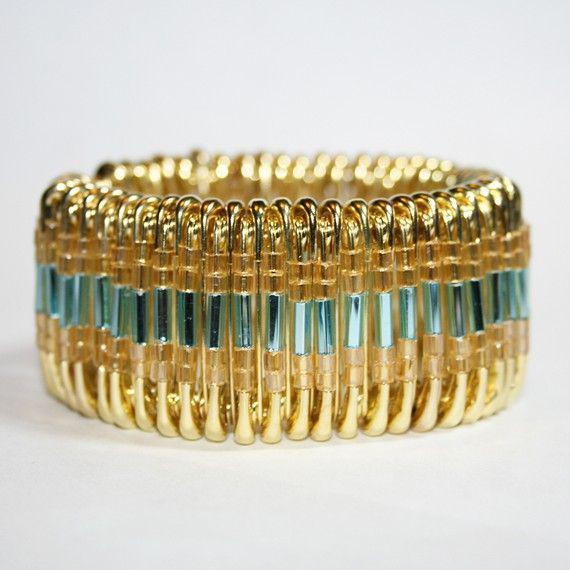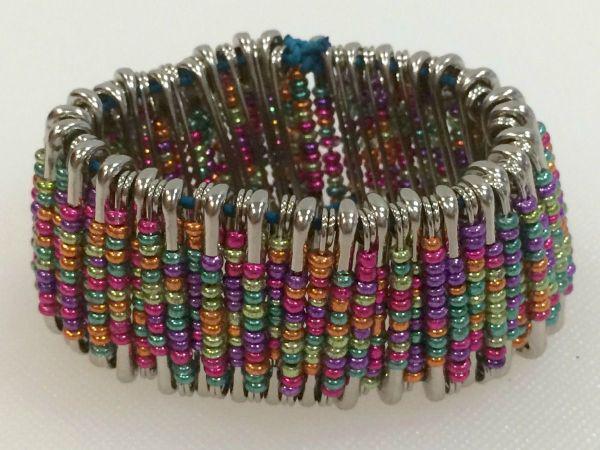The first image is the image on the left, the second image is the image on the right. Assess this claim about the two images: "One of the bracelets features small, round, rainbow colored beads including the colors pink and orange.". Correct or not? Answer yes or no. Yes. The first image is the image on the left, the second image is the image on the right. Examine the images to the left and right. Is the description "jewelry made from bobby pins are on human wrists" accurate? Answer yes or no. No. 